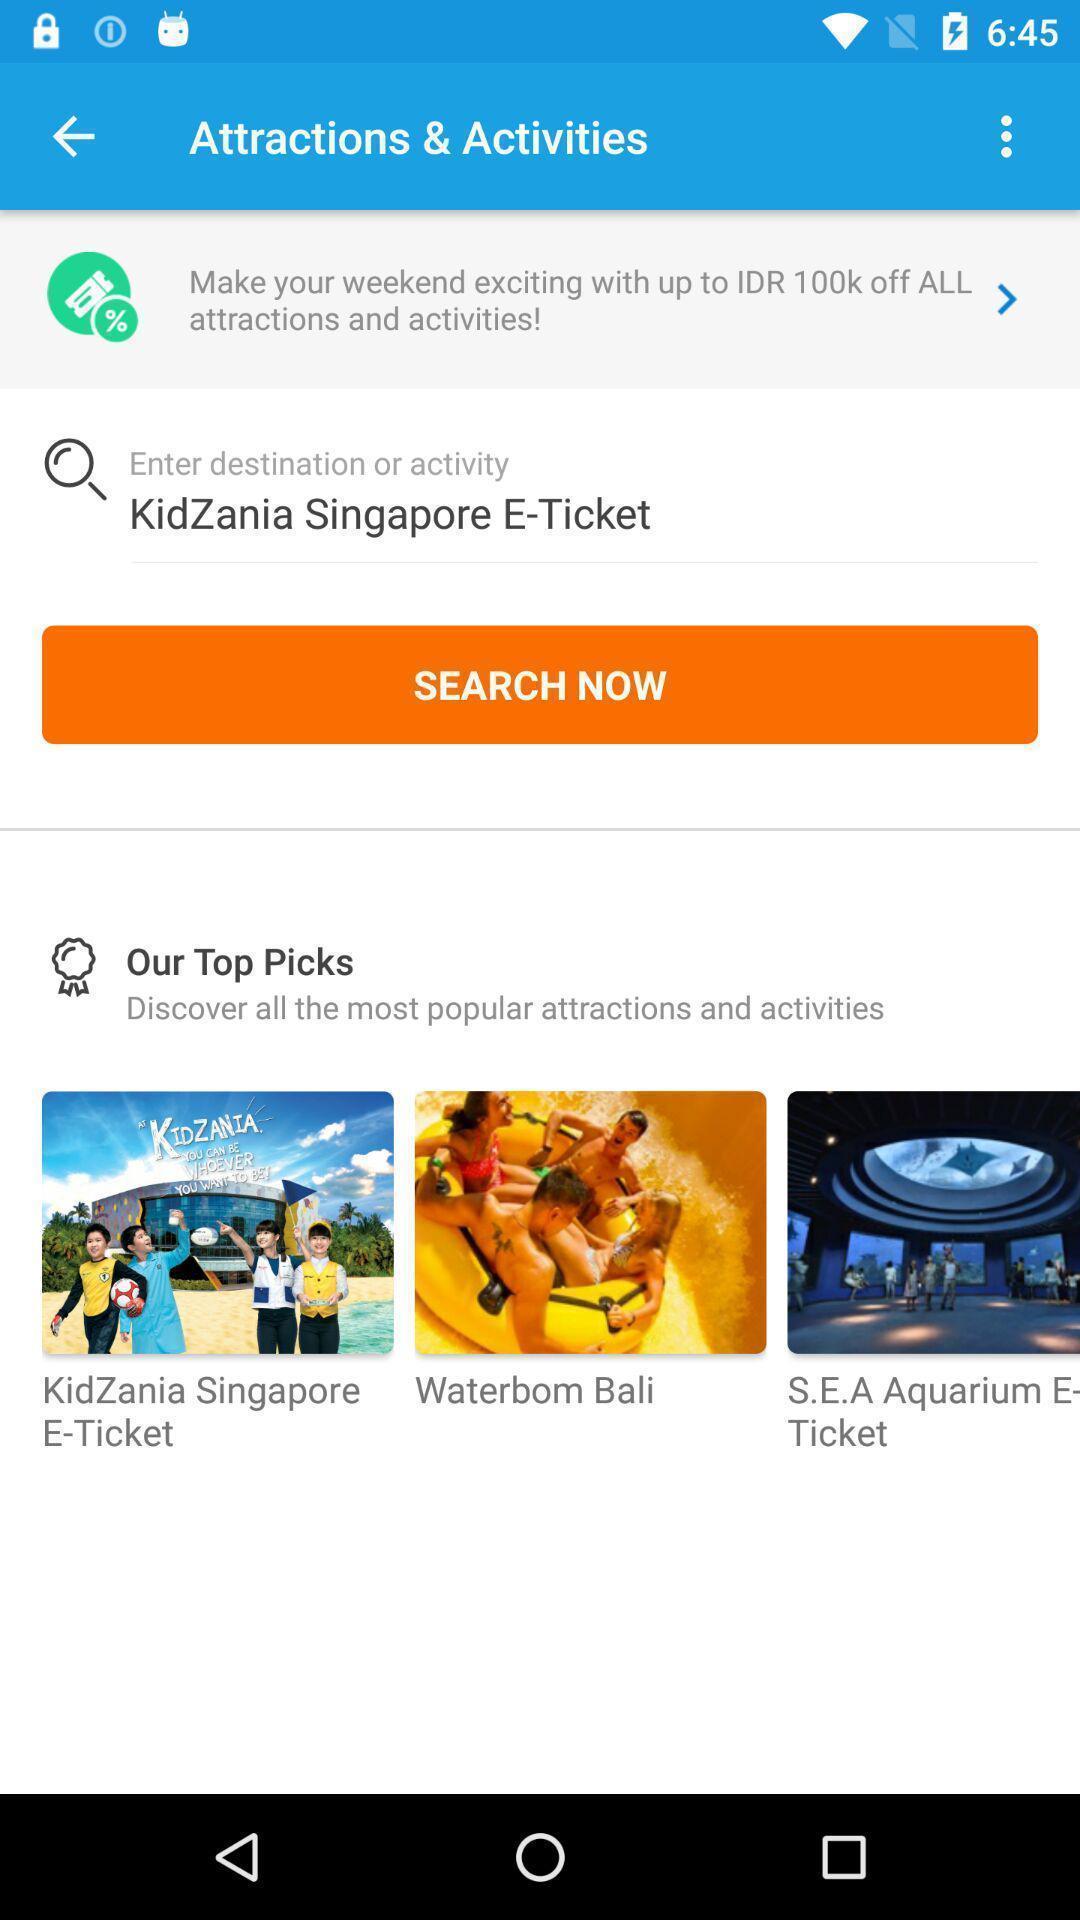Describe this image in words. Search page in an online airlines app. 